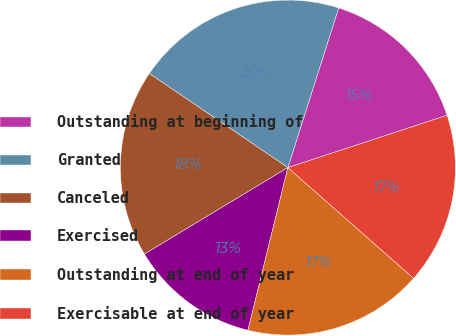Convert chart to OTSL. <chart><loc_0><loc_0><loc_500><loc_500><pie_chart><fcel>Outstanding at beginning of<fcel>Granted<fcel>Canceled<fcel>Exercised<fcel>Outstanding at end of year<fcel>Exercisable at end of year<nl><fcel>15.05%<fcel>20.41%<fcel>18.13%<fcel>12.53%<fcel>17.34%<fcel>16.55%<nl></chart> 